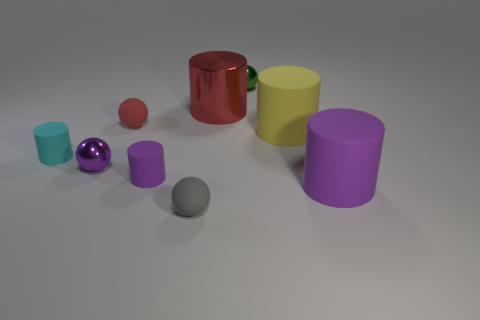There is a tiny sphere that is the same color as the metallic cylinder; what material is it?
Offer a very short reply. Rubber. Is the number of yellow metal cylinders greater than the number of large yellow cylinders?
Offer a very short reply. No. Does the red rubber sphere have the same size as the cyan matte thing?
Your answer should be compact. Yes. How many objects are tiny shiny spheres or small green shiny spheres?
Your response must be concise. 2. The large red object that is to the left of the metal ball behind the big rubber object that is behind the small purple rubber thing is what shape?
Offer a terse response. Cylinder. Does the small purple thing that is on the left side of the tiny purple matte thing have the same material as the purple object to the right of the green sphere?
Your response must be concise. No. What material is the small purple thing that is the same shape as the yellow rubber object?
Provide a succinct answer. Rubber. Is there any other thing that is the same size as the metal cylinder?
Your response must be concise. Yes. There is a large matte thing that is to the left of the big purple rubber cylinder; is its shape the same as the rubber object left of the purple ball?
Your response must be concise. Yes. Are there fewer metallic cylinders left of the tiny red matte thing than tiny red rubber balls on the right side of the small gray thing?
Make the answer very short. No. 